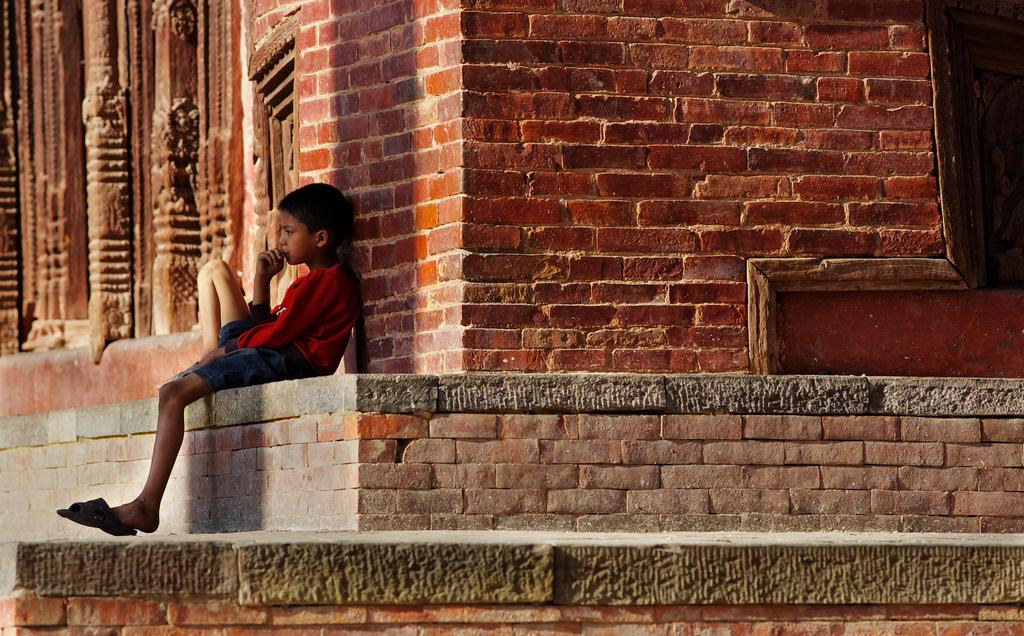Who is the main subject in the image? There is a boy in the image. What is the boy doing in the image? The boy is sitting on the side of a wall. What is the boy wearing in the image? The boy is wearing a red color T-shirt and a blue color short. What can be seen on the right side of the image? There is a brick wall on the right side of the image. Can you see any clouds in the image? There is no mention of clouds in the provided facts, and therefore we cannot determine if clouds are present in the image. 